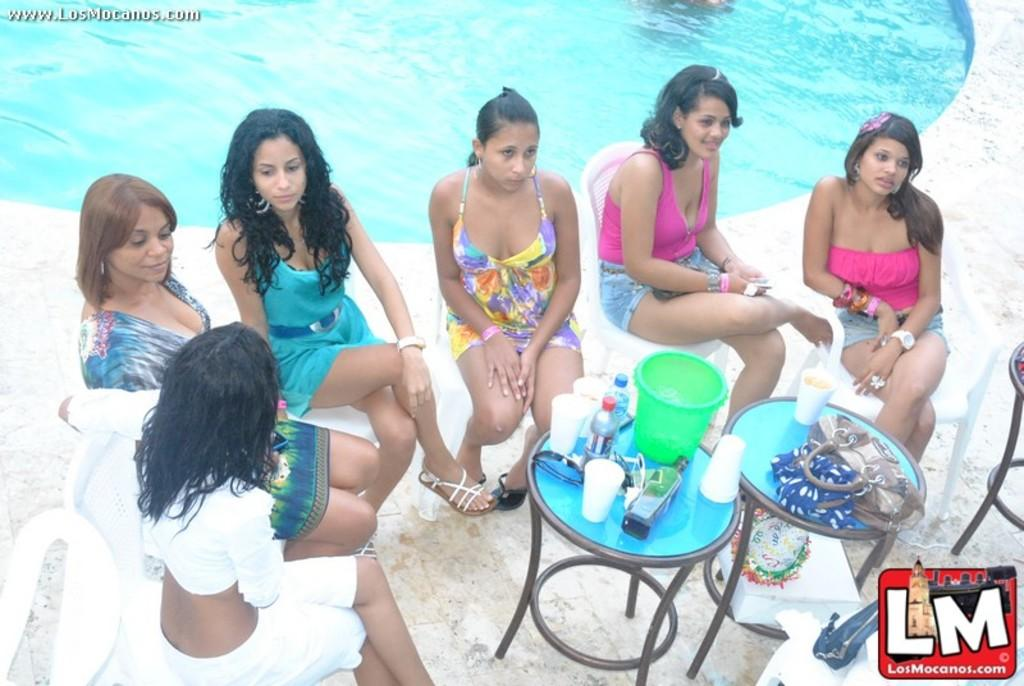What are the persons in the image doing? The persons in the image are sitting on chairs. What type of containers can be seen in the image? There are bottles, cups, and a bucket in the image. What other item is present in the image? There is a bag in the image. What can be seen in the background of the image? There is a swimming pool in the background of the image. What type of lip can be seen on the persons in the image? There is no lip visible on the persons in the image. What is the glue used for in the image? There is no glue present in the image. 